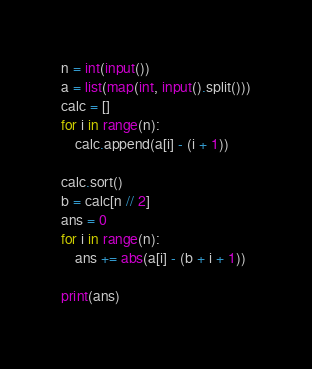<code> <loc_0><loc_0><loc_500><loc_500><_Python_>
n = int(input())
a = list(map(int, input().split()))
calc = []
for i in range(n):
    calc.append(a[i] - (i + 1))

calc.sort()
b = calc[n // 2]
ans = 0
for i in range(n):
    ans += abs(a[i] - (b + i + 1))

print(ans)</code> 